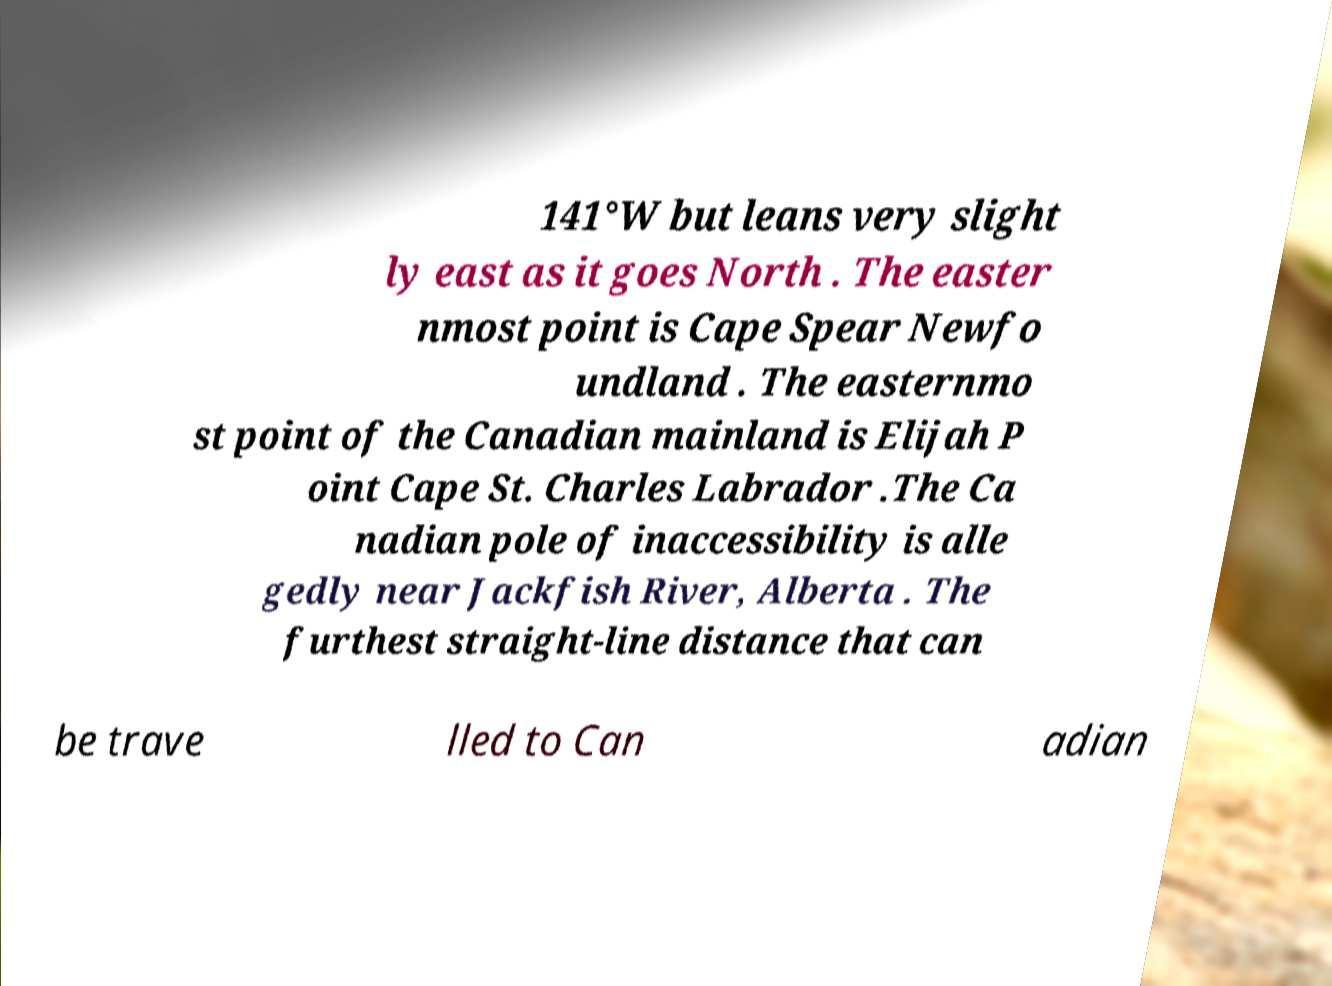Could you assist in decoding the text presented in this image and type it out clearly? 141°W but leans very slight ly east as it goes North . The easter nmost point is Cape Spear Newfo undland . The easternmo st point of the Canadian mainland is Elijah P oint Cape St. Charles Labrador .The Ca nadian pole of inaccessibility is alle gedly near Jackfish River, Alberta . The furthest straight-line distance that can be trave lled to Can adian 